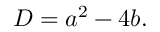Convert formula to latex. <formula><loc_0><loc_0><loc_500><loc_500>D = a ^ { 2 } - 4 b .</formula> 